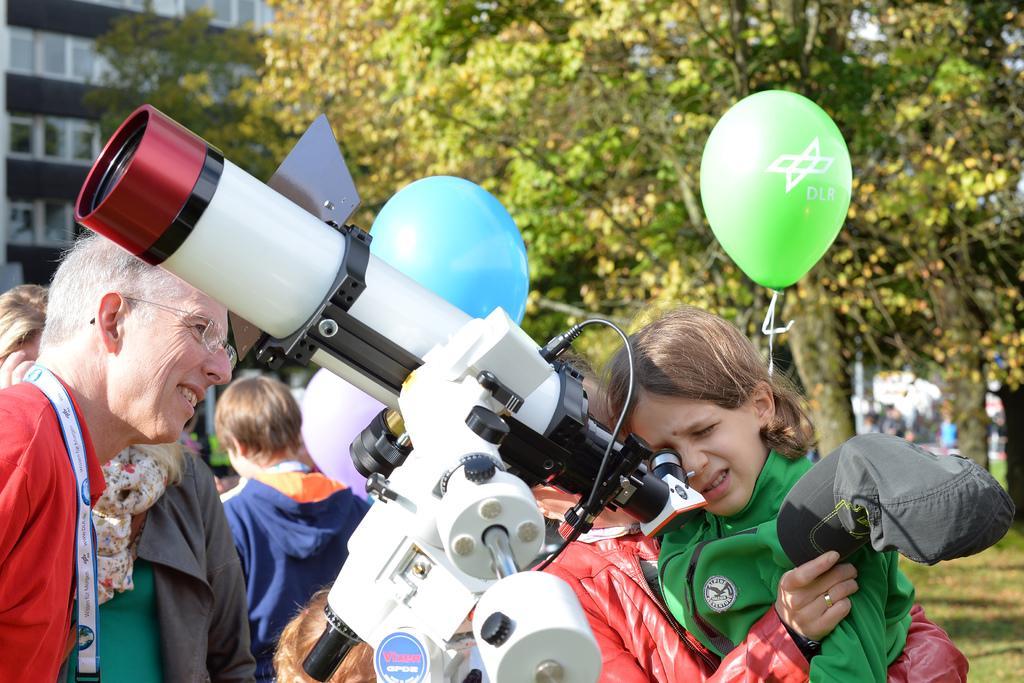Can you describe this image briefly? In this picture I can see building and trees and few people standing and I can see telescope and I can see balloons and grass on the ground. 